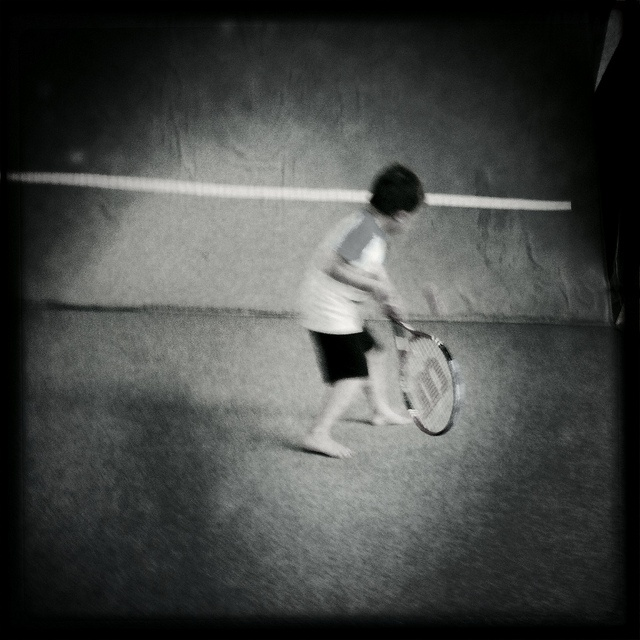Describe the objects in this image and their specific colors. I can see people in black, darkgray, lightgray, and gray tones, tennis racket in black, darkgray, gray, and lightgray tones, and sports ball in black, darkgray, and gray tones in this image. 